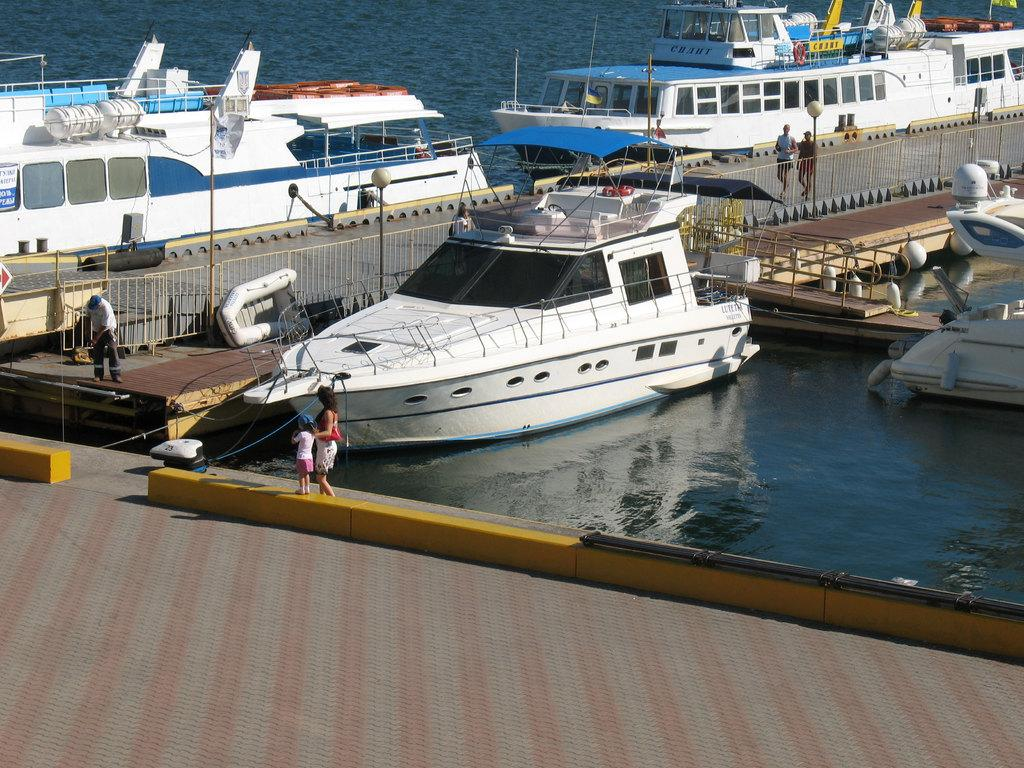What type of vehicles can be seen on the water in the image? There are many boats with windows on the water in the image. What structure is present near the water? There is a deck with railings near the water. Are there any people visible in the image? Yes, there are people present in the image. What can be seen in the background of the image? There is a road visible in the background, and there are light poles on the side of the road. What type of frame is holding the flower in the image? There is no frame or flower present in the image. What knowledge can be gained from the image? The image provides visual information about boats, a deck, people, a road, and light poles, but it does not convey any specific knowledge or teach any lessons. 